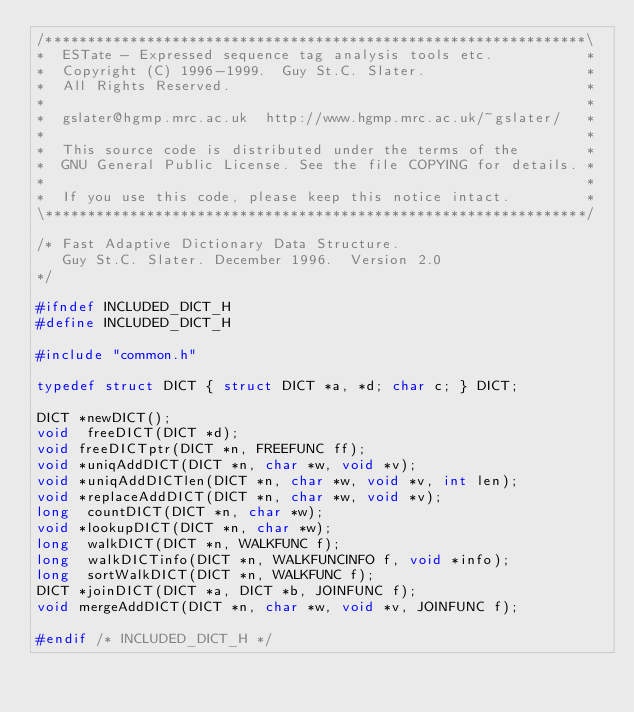<code> <loc_0><loc_0><loc_500><loc_500><_C_>/****************************************************************\
*  ESTate - Expressed sequence tag analysis tools etc.           *
*  Copyright (C) 1996-1999.  Guy St.C. Slater.                   *
*  All Rights Reserved.                                          *
*                                                                *
*  gslater@hgmp.mrc.ac.uk  http://www.hgmp.mrc.ac.uk/~gslater/   *
*                                                                *
*  This source code is distributed under the terms of the        *
*  GNU General Public License. See the file COPYING for details. *
*                                                                *
*  If you use this code, please keep this notice intact.         *
\****************************************************************/

/* Fast Adaptive Dictionary Data Structure.
   Guy St.C. Slater. December 1996.  Version 2.0
*/

#ifndef INCLUDED_DICT_H
#define INCLUDED_DICT_H

#include "common.h"

typedef struct DICT { struct DICT *a, *d; char c; } DICT;

DICT *newDICT();
void  freeDICT(DICT *d);
void freeDICTptr(DICT *n, FREEFUNC ff);
void *uniqAddDICT(DICT *n, char *w, void *v);
void *uniqAddDICTlen(DICT *n, char *w, void *v, int len);
void *replaceAddDICT(DICT *n, char *w, void *v);
long  countDICT(DICT *n, char *w);
void *lookupDICT(DICT *n, char *w);
long  walkDICT(DICT *n, WALKFUNC f);
long  walkDICTinfo(DICT *n, WALKFUNCINFO f, void *info);
long  sortWalkDICT(DICT *n, WALKFUNC f);
DICT *joinDICT(DICT *a, DICT *b, JOINFUNC f);
void mergeAddDICT(DICT *n, char *w, void *v, JOINFUNC f);

#endif /* INCLUDED_DICT_H */

</code> 